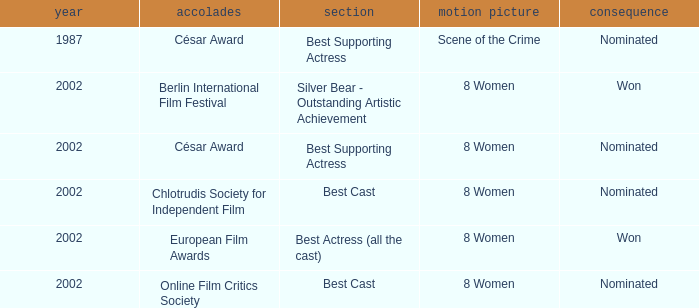What was the categorie in 2002 at the Berlin international Film Festival that Danielle Darrieux was in? Silver Bear - Outstanding Artistic Achievement. 